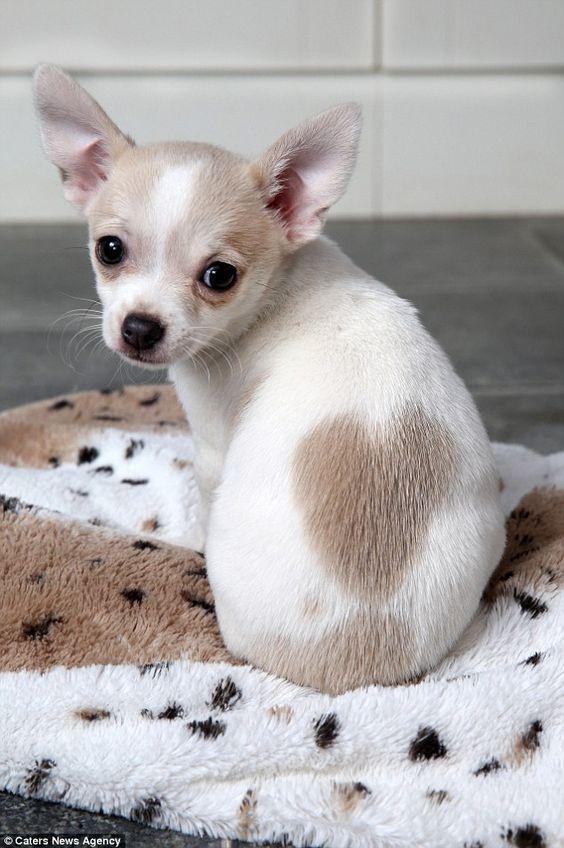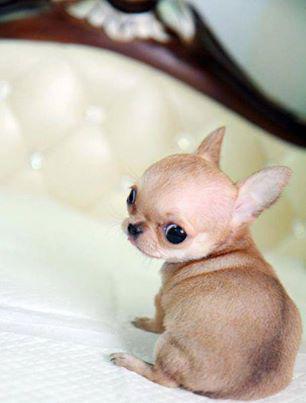The first image is the image on the left, the second image is the image on the right. Given the left and right images, does the statement "A person's hand is shown in one of the images." hold true? Answer yes or no. No. 